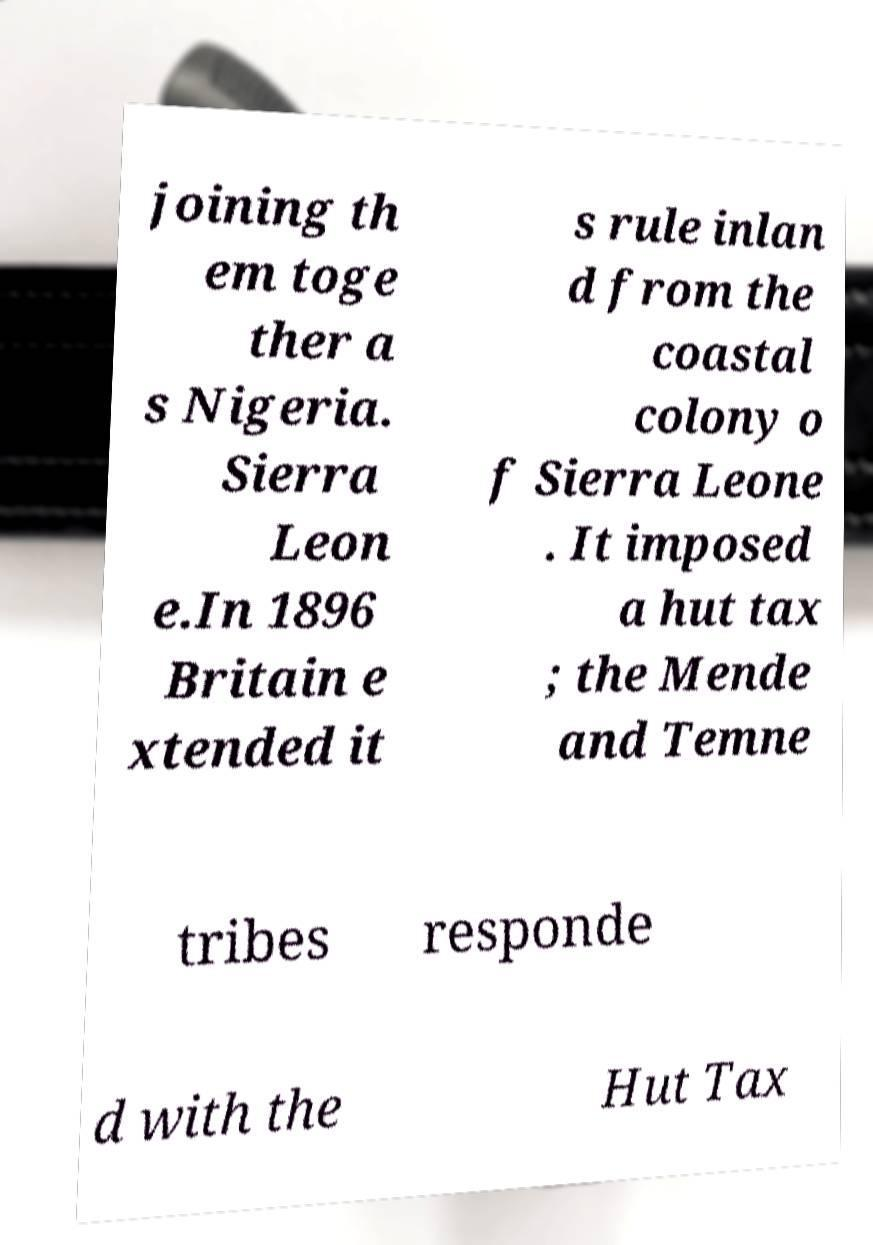Could you assist in decoding the text presented in this image and type it out clearly? joining th em toge ther a s Nigeria. Sierra Leon e.In 1896 Britain e xtended it s rule inlan d from the coastal colony o f Sierra Leone . It imposed a hut tax ; the Mende and Temne tribes responde d with the Hut Tax 